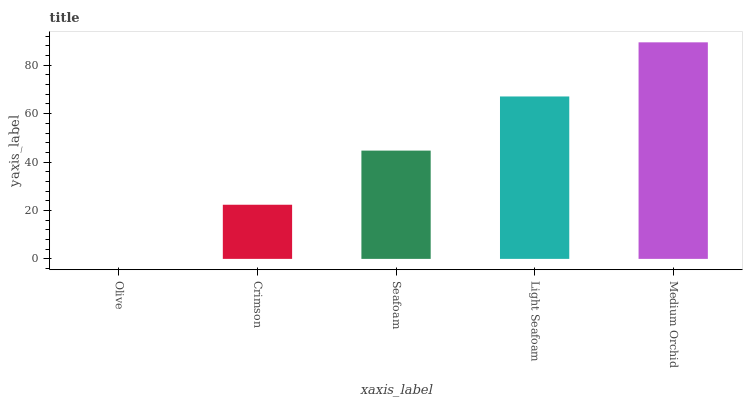Is Olive the minimum?
Answer yes or no. Yes. Is Medium Orchid the maximum?
Answer yes or no. Yes. Is Crimson the minimum?
Answer yes or no. No. Is Crimson the maximum?
Answer yes or no. No. Is Crimson greater than Olive?
Answer yes or no. Yes. Is Olive less than Crimson?
Answer yes or no. Yes. Is Olive greater than Crimson?
Answer yes or no. No. Is Crimson less than Olive?
Answer yes or no. No. Is Seafoam the high median?
Answer yes or no. Yes. Is Seafoam the low median?
Answer yes or no. Yes. Is Crimson the high median?
Answer yes or no. No. Is Olive the low median?
Answer yes or no. No. 